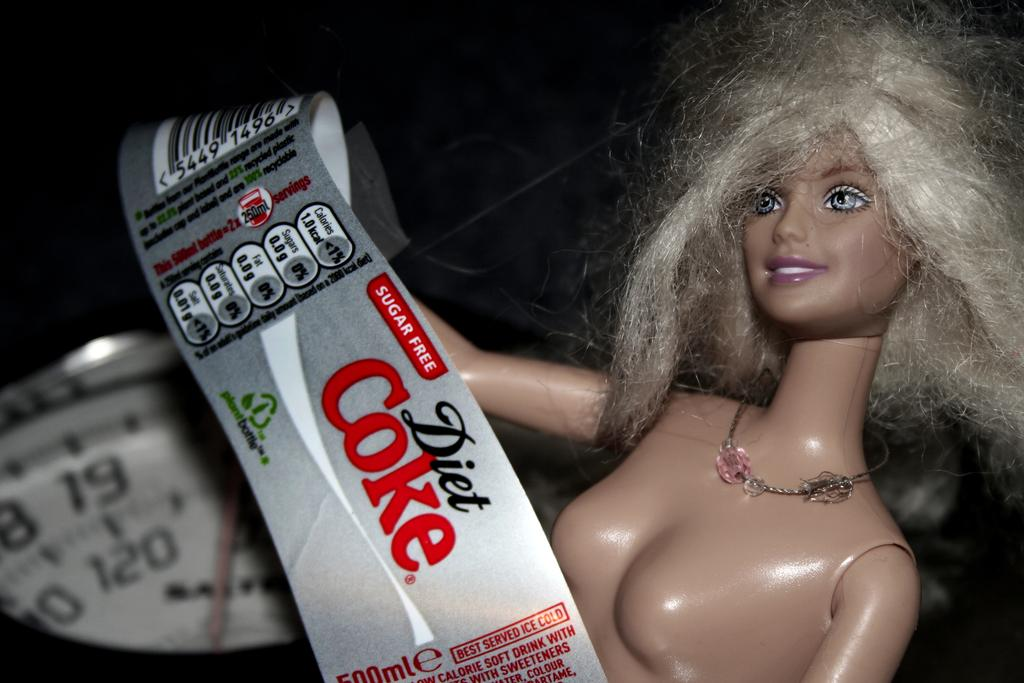What is the main subject of the image? The main subject of the image is a doll. Is there any text or labeling in the image? Yes, there is a label in the image. What other object can be seen in the image? There is an object that looks like a weighing scale in the image. What is the color of the background in the image? The background of the image is dark. What type of smell can be detected from the doll in the image? There is no indication of smell in the image, as it is a visual medium. --- Facts: 1. There is a person in the image. 2. The person is wearing a hat. 3. The person is holding a book. 4. There is a table in the image. 5. The table has a lamp on it. Absurd Topics: dance, ocean, bird Conversation: Who is the main subject of the image? The main subject of the image is a person. What is the person wearing in the image? The person is wearing a hat in the image. What is the person holding in the image? The person is holding a book in the image. What object can be seen on the table in the image? There is a lamp on the table in the image. Reasoning: Let's think step by step in order to produce the conversation. We start by identifying the main subject of the image, which is the person. Then, we describe the person's attire and what they are holding, which is a hat and a book, respectively. Finally, we mention the table and the lamp on it to provide additional context about the setting. Absurd Question/Answer: Can you see any birds flying over the ocean in the image? There is no ocean or birds present in the image; it features a person holding a book and wearing a hat. 